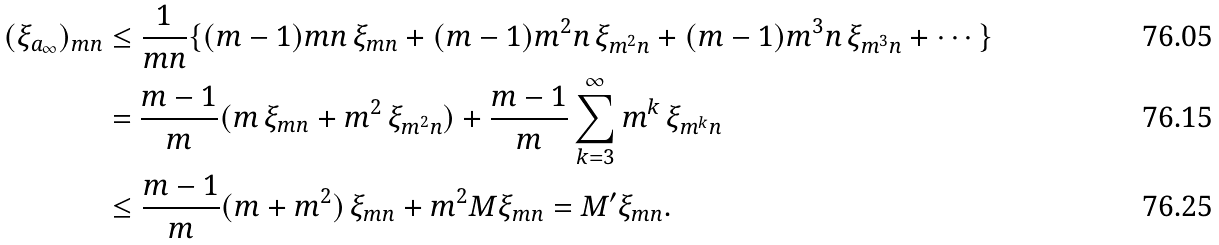Convert formula to latex. <formula><loc_0><loc_0><loc_500><loc_500>( \xi _ { a _ { \infty } } ) _ { m n } & \leq \frac { 1 } { m n } \{ ( m - 1 ) m n \, \xi _ { m n } + ( m - 1 ) m ^ { 2 } n \, \xi _ { m ^ { 2 } n } + ( m - 1 ) m ^ { 3 } n \, \xi _ { m ^ { 3 } n } + \cdots \} \\ & = \frac { m - 1 } { m } ( m \, \xi _ { m n } + m ^ { 2 } \, \xi _ { m ^ { 2 } n } ) + \frac { m - 1 } { m } \sum _ { k = 3 } ^ { \infty } m ^ { k } \, \xi _ { m ^ { k } n } \\ & \leq \frac { m - 1 } { m } ( m + m ^ { 2 } ) \, \xi _ { m n } + m ^ { 2 } M \xi _ { m n } = M ^ { \prime } \xi _ { m n } .</formula> 